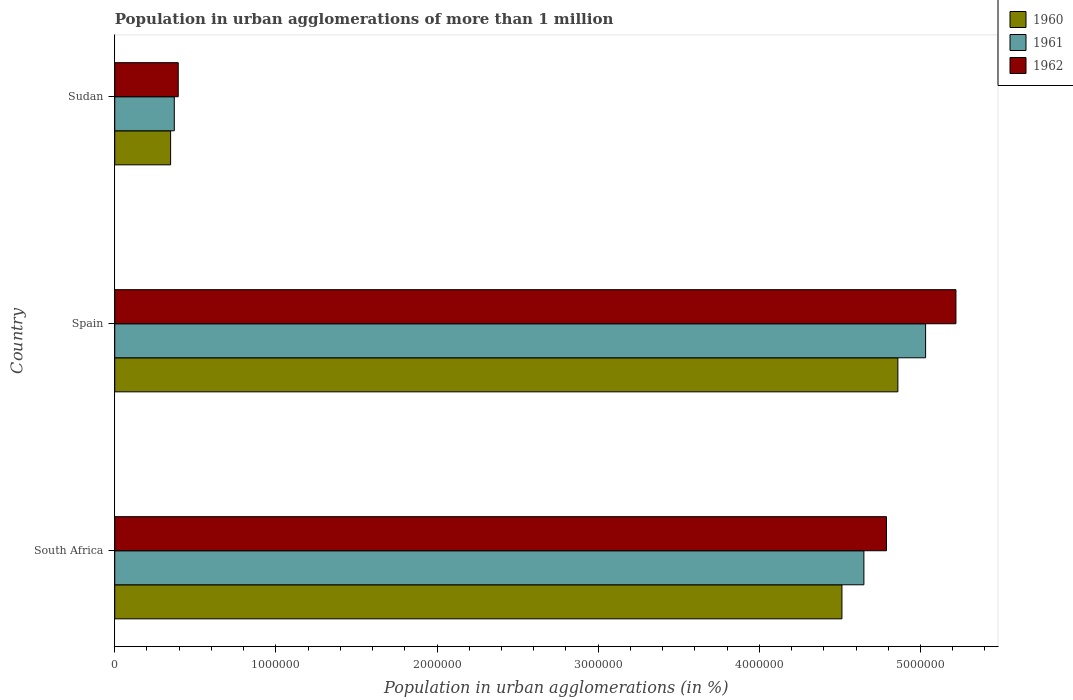How many bars are there on the 1st tick from the bottom?
Your response must be concise. 3. What is the label of the 2nd group of bars from the top?
Offer a terse response. Spain. What is the population in urban agglomerations in 1962 in Sudan?
Provide a succinct answer. 3.94e+05. Across all countries, what is the maximum population in urban agglomerations in 1960?
Keep it short and to the point. 4.86e+06. Across all countries, what is the minimum population in urban agglomerations in 1960?
Make the answer very short. 3.47e+05. In which country was the population in urban agglomerations in 1960 maximum?
Provide a succinct answer. Spain. In which country was the population in urban agglomerations in 1962 minimum?
Offer a terse response. Sudan. What is the total population in urban agglomerations in 1960 in the graph?
Give a very brief answer. 9.72e+06. What is the difference between the population in urban agglomerations in 1960 in Spain and that in Sudan?
Give a very brief answer. 4.51e+06. What is the difference between the population in urban agglomerations in 1962 in Spain and the population in urban agglomerations in 1960 in South Africa?
Provide a short and direct response. 7.07e+05. What is the average population in urban agglomerations in 1960 per country?
Your answer should be very brief. 3.24e+06. What is the difference between the population in urban agglomerations in 1961 and population in urban agglomerations in 1962 in South Africa?
Ensure brevity in your answer.  -1.40e+05. What is the ratio of the population in urban agglomerations in 1960 in South Africa to that in Spain?
Make the answer very short. 0.93. Is the difference between the population in urban agglomerations in 1961 in Spain and Sudan greater than the difference between the population in urban agglomerations in 1962 in Spain and Sudan?
Ensure brevity in your answer.  No. What is the difference between the highest and the second highest population in urban agglomerations in 1960?
Provide a short and direct response. 3.47e+05. What is the difference between the highest and the lowest population in urban agglomerations in 1960?
Your answer should be very brief. 4.51e+06. Is the sum of the population in urban agglomerations in 1960 in South Africa and Sudan greater than the maximum population in urban agglomerations in 1962 across all countries?
Offer a very short reply. No. What does the 2nd bar from the top in Spain represents?
Your answer should be very brief. 1961. What does the 3rd bar from the bottom in Spain represents?
Give a very brief answer. 1962. Is it the case that in every country, the sum of the population in urban agglomerations in 1962 and population in urban agglomerations in 1960 is greater than the population in urban agglomerations in 1961?
Provide a succinct answer. Yes. Are all the bars in the graph horizontal?
Offer a terse response. Yes. Does the graph contain grids?
Ensure brevity in your answer.  No. Where does the legend appear in the graph?
Keep it short and to the point. Top right. How many legend labels are there?
Your answer should be compact. 3. How are the legend labels stacked?
Provide a succinct answer. Vertical. What is the title of the graph?
Provide a succinct answer. Population in urban agglomerations of more than 1 million. Does "1963" appear as one of the legend labels in the graph?
Offer a terse response. No. What is the label or title of the X-axis?
Your response must be concise. Population in urban agglomerations (in %). What is the label or title of the Y-axis?
Make the answer very short. Country. What is the Population in urban agglomerations (in %) in 1960 in South Africa?
Your answer should be very brief. 4.51e+06. What is the Population in urban agglomerations (in %) of 1961 in South Africa?
Your answer should be very brief. 4.65e+06. What is the Population in urban agglomerations (in %) of 1962 in South Africa?
Make the answer very short. 4.79e+06. What is the Population in urban agglomerations (in %) in 1960 in Spain?
Give a very brief answer. 4.86e+06. What is the Population in urban agglomerations (in %) of 1961 in Spain?
Your answer should be very brief. 5.03e+06. What is the Population in urban agglomerations (in %) in 1962 in Spain?
Provide a short and direct response. 5.22e+06. What is the Population in urban agglomerations (in %) of 1960 in Sudan?
Your answer should be compact. 3.47e+05. What is the Population in urban agglomerations (in %) of 1961 in Sudan?
Give a very brief answer. 3.69e+05. What is the Population in urban agglomerations (in %) in 1962 in Sudan?
Make the answer very short. 3.94e+05. Across all countries, what is the maximum Population in urban agglomerations (in %) of 1960?
Your response must be concise. 4.86e+06. Across all countries, what is the maximum Population in urban agglomerations (in %) of 1961?
Provide a short and direct response. 5.03e+06. Across all countries, what is the maximum Population in urban agglomerations (in %) of 1962?
Keep it short and to the point. 5.22e+06. Across all countries, what is the minimum Population in urban agglomerations (in %) in 1960?
Provide a succinct answer. 3.47e+05. Across all countries, what is the minimum Population in urban agglomerations (in %) in 1961?
Offer a terse response. 3.69e+05. Across all countries, what is the minimum Population in urban agglomerations (in %) of 1962?
Offer a very short reply. 3.94e+05. What is the total Population in urban agglomerations (in %) in 1960 in the graph?
Give a very brief answer. 9.72e+06. What is the total Population in urban agglomerations (in %) in 1961 in the graph?
Provide a succinct answer. 1.00e+07. What is the total Population in urban agglomerations (in %) in 1962 in the graph?
Make the answer very short. 1.04e+07. What is the difference between the Population in urban agglomerations (in %) in 1960 in South Africa and that in Spain?
Provide a short and direct response. -3.47e+05. What is the difference between the Population in urban agglomerations (in %) in 1961 in South Africa and that in Spain?
Your answer should be compact. -3.83e+05. What is the difference between the Population in urban agglomerations (in %) of 1962 in South Africa and that in Spain?
Your answer should be compact. -4.31e+05. What is the difference between the Population in urban agglomerations (in %) of 1960 in South Africa and that in Sudan?
Offer a very short reply. 4.17e+06. What is the difference between the Population in urban agglomerations (in %) in 1961 in South Africa and that in Sudan?
Your answer should be very brief. 4.28e+06. What is the difference between the Population in urban agglomerations (in %) in 1962 in South Africa and that in Sudan?
Your answer should be very brief. 4.39e+06. What is the difference between the Population in urban agglomerations (in %) in 1960 in Spain and that in Sudan?
Your response must be concise. 4.51e+06. What is the difference between the Population in urban agglomerations (in %) of 1961 in Spain and that in Sudan?
Your response must be concise. 4.66e+06. What is the difference between the Population in urban agglomerations (in %) in 1962 in Spain and that in Sudan?
Provide a succinct answer. 4.83e+06. What is the difference between the Population in urban agglomerations (in %) of 1960 in South Africa and the Population in urban agglomerations (in %) of 1961 in Spain?
Make the answer very short. -5.19e+05. What is the difference between the Population in urban agglomerations (in %) in 1960 in South Africa and the Population in urban agglomerations (in %) in 1962 in Spain?
Keep it short and to the point. -7.07e+05. What is the difference between the Population in urban agglomerations (in %) of 1961 in South Africa and the Population in urban agglomerations (in %) of 1962 in Spain?
Ensure brevity in your answer.  -5.71e+05. What is the difference between the Population in urban agglomerations (in %) in 1960 in South Africa and the Population in urban agglomerations (in %) in 1961 in Sudan?
Offer a terse response. 4.14e+06. What is the difference between the Population in urban agglomerations (in %) in 1960 in South Africa and the Population in urban agglomerations (in %) in 1962 in Sudan?
Your answer should be compact. 4.12e+06. What is the difference between the Population in urban agglomerations (in %) in 1961 in South Africa and the Population in urban agglomerations (in %) in 1962 in Sudan?
Offer a terse response. 4.25e+06. What is the difference between the Population in urban agglomerations (in %) of 1960 in Spain and the Population in urban agglomerations (in %) of 1961 in Sudan?
Keep it short and to the point. 4.49e+06. What is the difference between the Population in urban agglomerations (in %) of 1960 in Spain and the Population in urban agglomerations (in %) of 1962 in Sudan?
Make the answer very short. 4.47e+06. What is the difference between the Population in urban agglomerations (in %) in 1961 in Spain and the Population in urban agglomerations (in %) in 1962 in Sudan?
Your answer should be compact. 4.64e+06. What is the average Population in urban agglomerations (in %) of 1960 per country?
Offer a very short reply. 3.24e+06. What is the average Population in urban agglomerations (in %) of 1961 per country?
Make the answer very short. 3.35e+06. What is the average Population in urban agglomerations (in %) in 1962 per country?
Give a very brief answer. 3.47e+06. What is the difference between the Population in urban agglomerations (in %) in 1960 and Population in urban agglomerations (in %) in 1961 in South Africa?
Make the answer very short. -1.36e+05. What is the difference between the Population in urban agglomerations (in %) of 1960 and Population in urban agglomerations (in %) of 1962 in South Africa?
Make the answer very short. -2.76e+05. What is the difference between the Population in urban agglomerations (in %) in 1961 and Population in urban agglomerations (in %) in 1962 in South Africa?
Provide a short and direct response. -1.40e+05. What is the difference between the Population in urban agglomerations (in %) in 1960 and Population in urban agglomerations (in %) in 1961 in Spain?
Provide a succinct answer. -1.72e+05. What is the difference between the Population in urban agglomerations (in %) in 1960 and Population in urban agglomerations (in %) in 1962 in Spain?
Provide a succinct answer. -3.60e+05. What is the difference between the Population in urban agglomerations (in %) of 1961 and Population in urban agglomerations (in %) of 1962 in Spain?
Make the answer very short. -1.88e+05. What is the difference between the Population in urban agglomerations (in %) in 1960 and Population in urban agglomerations (in %) in 1961 in Sudan?
Make the answer very short. -2.29e+04. What is the difference between the Population in urban agglomerations (in %) in 1960 and Population in urban agglomerations (in %) in 1962 in Sudan?
Your response must be concise. -4.73e+04. What is the difference between the Population in urban agglomerations (in %) of 1961 and Population in urban agglomerations (in %) of 1962 in Sudan?
Offer a very short reply. -2.44e+04. What is the ratio of the Population in urban agglomerations (in %) in 1960 in South Africa to that in Spain?
Make the answer very short. 0.93. What is the ratio of the Population in urban agglomerations (in %) of 1961 in South Africa to that in Spain?
Your response must be concise. 0.92. What is the ratio of the Population in urban agglomerations (in %) of 1962 in South Africa to that in Spain?
Provide a short and direct response. 0.92. What is the ratio of the Population in urban agglomerations (in %) of 1960 in South Africa to that in Sudan?
Provide a short and direct response. 13.02. What is the ratio of the Population in urban agglomerations (in %) of 1961 in South Africa to that in Sudan?
Offer a terse response. 12.58. What is the ratio of the Population in urban agglomerations (in %) in 1962 in South Africa to that in Sudan?
Provide a succinct answer. 12.16. What is the ratio of the Population in urban agglomerations (in %) in 1960 in Spain to that in Sudan?
Your answer should be very brief. 14.02. What is the ratio of the Population in urban agglomerations (in %) in 1961 in Spain to that in Sudan?
Keep it short and to the point. 13.62. What is the ratio of the Population in urban agglomerations (in %) of 1962 in Spain to that in Sudan?
Ensure brevity in your answer.  13.25. What is the difference between the highest and the second highest Population in urban agglomerations (in %) of 1960?
Keep it short and to the point. 3.47e+05. What is the difference between the highest and the second highest Population in urban agglomerations (in %) in 1961?
Offer a terse response. 3.83e+05. What is the difference between the highest and the second highest Population in urban agglomerations (in %) in 1962?
Provide a short and direct response. 4.31e+05. What is the difference between the highest and the lowest Population in urban agglomerations (in %) in 1960?
Give a very brief answer. 4.51e+06. What is the difference between the highest and the lowest Population in urban agglomerations (in %) in 1961?
Provide a succinct answer. 4.66e+06. What is the difference between the highest and the lowest Population in urban agglomerations (in %) in 1962?
Give a very brief answer. 4.83e+06. 